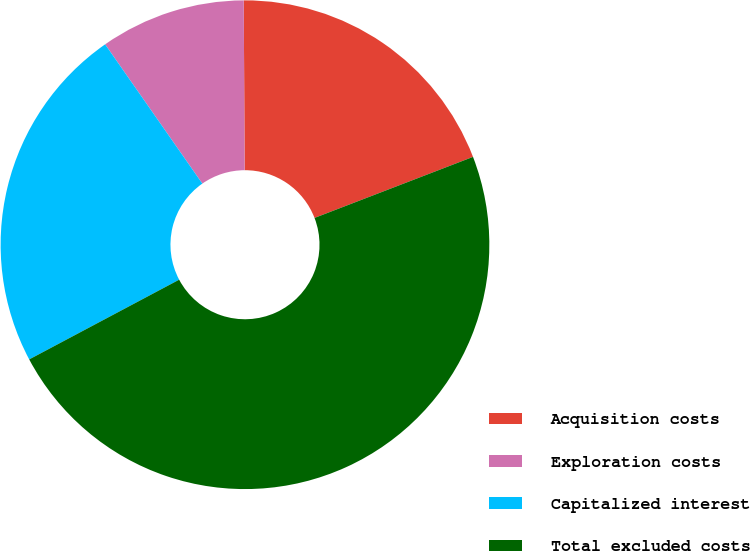<chart> <loc_0><loc_0><loc_500><loc_500><pie_chart><fcel>Acquisition costs<fcel>Exploration costs<fcel>Capitalized interest<fcel>Total excluded costs<nl><fcel>19.23%<fcel>9.62%<fcel>23.08%<fcel>48.08%<nl></chart> 